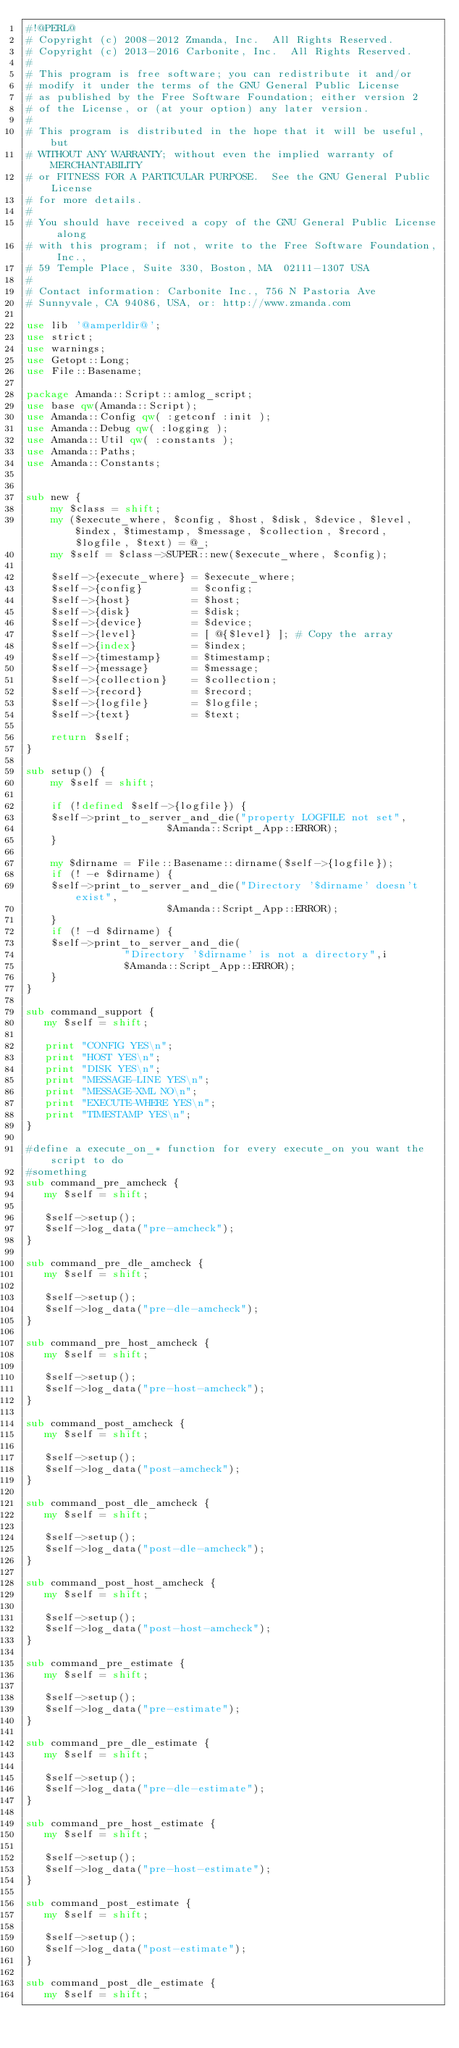Convert code to text. <code><loc_0><loc_0><loc_500><loc_500><_Perl_>#!@PERL@
# Copyright (c) 2008-2012 Zmanda, Inc.  All Rights Reserved.
# Copyright (c) 2013-2016 Carbonite, Inc.  All Rights Reserved.
#
# This program is free software; you can redistribute it and/or
# modify it under the terms of the GNU General Public License
# as published by the Free Software Foundation; either version 2
# of the License, or (at your option) any later version.
#
# This program is distributed in the hope that it will be useful, but
# WITHOUT ANY WARRANTY; without even the implied warranty of MERCHANTABILITY
# or FITNESS FOR A PARTICULAR PURPOSE.  See the GNU General Public License
# for more details.
#
# You should have received a copy of the GNU General Public License along
# with this program; if not, write to the Free Software Foundation, Inc.,
# 59 Temple Place, Suite 330, Boston, MA  02111-1307 USA
#
# Contact information: Carbonite Inc., 756 N Pastoria Ave
# Sunnyvale, CA 94086, USA, or: http://www.zmanda.com

use lib '@amperldir@';
use strict;
use warnings;
use Getopt::Long;
use File::Basename;

package Amanda::Script::amlog_script;
use base qw(Amanda::Script);
use Amanda::Config qw( :getconf :init );
use Amanda::Debug qw( :logging );
use Amanda::Util qw( :constants );
use Amanda::Paths;
use Amanda::Constants;


sub new {
    my $class = shift;
    my ($execute_where, $config, $host, $disk, $device, $level, $index, $timestamp, $message, $collection, $record, $logfile, $text) = @_;
    my $self = $class->SUPER::new($execute_where, $config);

    $self->{execute_where} = $execute_where;
    $self->{config}        = $config;
    $self->{host}          = $host;
    $self->{disk}          = $disk;
    $self->{device}        = $device;
    $self->{level}         = [ @{$level} ]; # Copy the array
    $self->{index}         = $index;
    $self->{timestamp}     = $timestamp;
    $self->{message}       = $message;
    $self->{collection}    = $collection;
    $self->{record}        = $record;
    $self->{logfile}       = $logfile;
    $self->{text}          = $text;

    return $self;
}

sub setup() {
    my $self = shift;

    if (!defined $self->{logfile}) {
	$self->print_to_server_and_die("property LOGFILE not set",
				       $Amanda::Script_App::ERROR);
    }

    my $dirname = File::Basename::dirname($self->{logfile});
    if (! -e $dirname) {
	$self->print_to_server_and_die("Directory '$dirname' doesn't exist",
				       $Amanda::Script_App::ERROR);
    }
    if (! -d $dirname) {
	$self->print_to_server_and_die(
				"Directory '$dirname' is not a directory",i
				$Amanda::Script_App::ERROR);
    }
}

sub command_support {
   my $self = shift;

   print "CONFIG YES\n";
   print "HOST YES\n";
   print "DISK YES\n";
   print "MESSAGE-LINE YES\n";
   print "MESSAGE-XML NO\n";
   print "EXECUTE-WHERE YES\n";
   print "TIMESTAMP YES\n";
}

#define a execute_on_* function for every execute_on you want the script to do
#something
sub command_pre_amcheck {
   my $self = shift;

   $self->setup();
   $self->log_data("pre-amcheck");
}

sub command_pre_dle_amcheck {
   my $self = shift;

   $self->setup();
   $self->log_data("pre-dle-amcheck");
}

sub command_pre_host_amcheck {
   my $self = shift;

   $self->setup();
   $self->log_data("pre-host-amcheck");
}

sub command_post_amcheck {
   my $self = shift;

   $self->setup();
   $self->log_data("post-amcheck");
}

sub command_post_dle_amcheck {
   my $self = shift;

   $self->setup();
   $self->log_data("post-dle-amcheck");
}

sub command_post_host_amcheck {
   my $self = shift;

   $self->setup();
   $self->log_data("post-host-amcheck");
}

sub command_pre_estimate {
   my $self = shift;

   $self->setup();
   $self->log_data("pre-estimate");
}

sub command_pre_dle_estimate {
   my $self = shift;

   $self->setup();
   $self->log_data("pre-dle-estimate");
}

sub command_pre_host_estimate {
   my $self = shift;

   $self->setup();
   $self->log_data("pre-host-estimate");
}

sub command_post_estimate {
   my $self = shift;

   $self->setup();
   $self->log_data("post-estimate");
}

sub command_post_dle_estimate {
   my $self = shift;
</code> 